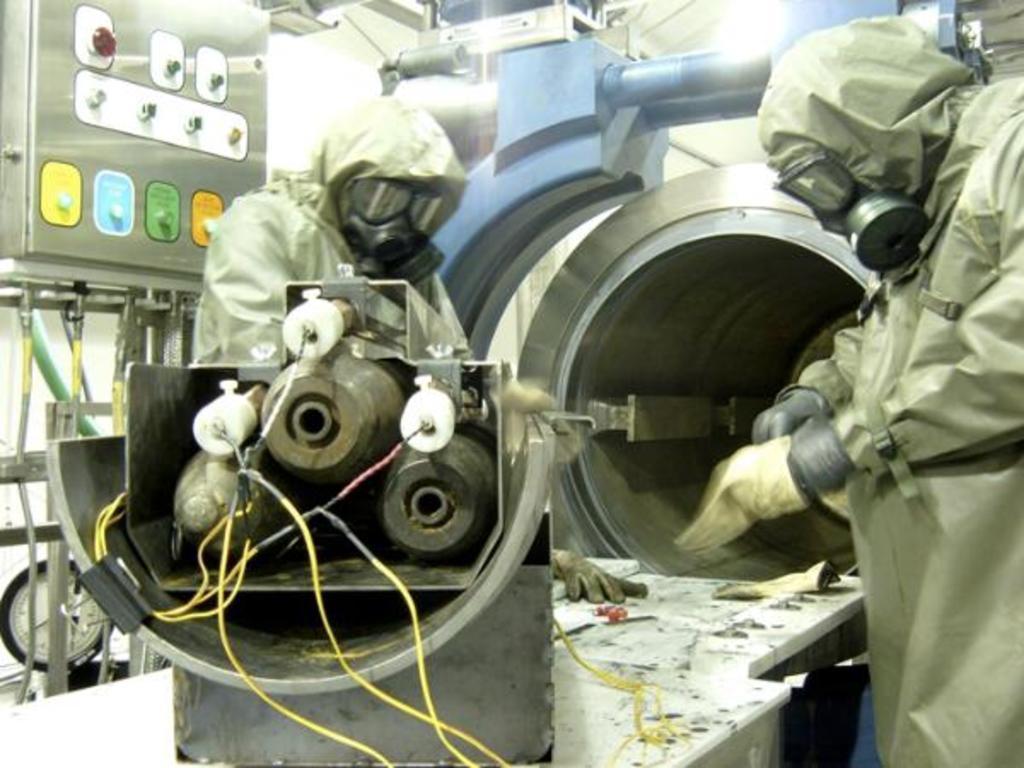In one or two sentences, can you explain what this image depicts? In this image I can see two persons are standing. I can see they both are wearing gloves, gas masks and coats. I can also see number of equipment in this image. 